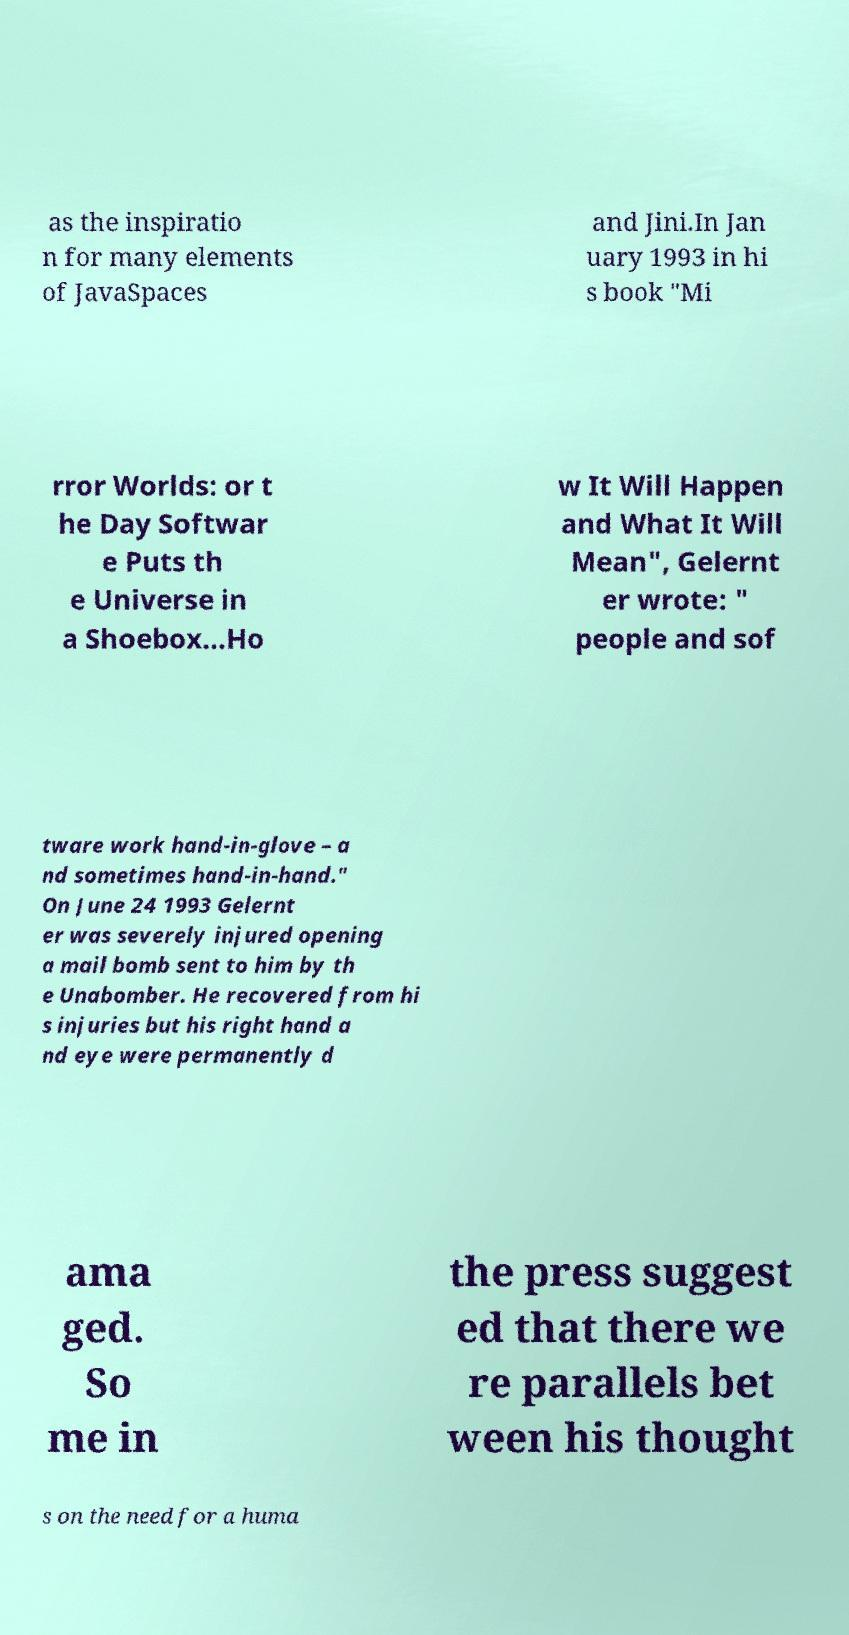Please read and relay the text visible in this image. What does it say? as the inspiratio n for many elements of JavaSpaces and Jini.In Jan uary 1993 in hi s book "Mi rror Worlds: or t he Day Softwar e Puts th e Universe in a Shoebox...Ho w It Will Happen and What It Will Mean", Gelernt er wrote: " people and sof tware work hand-in-glove – a nd sometimes hand-in-hand." On June 24 1993 Gelernt er was severely injured opening a mail bomb sent to him by th e Unabomber. He recovered from hi s injuries but his right hand a nd eye were permanently d ama ged. So me in the press suggest ed that there we re parallels bet ween his thought s on the need for a huma 